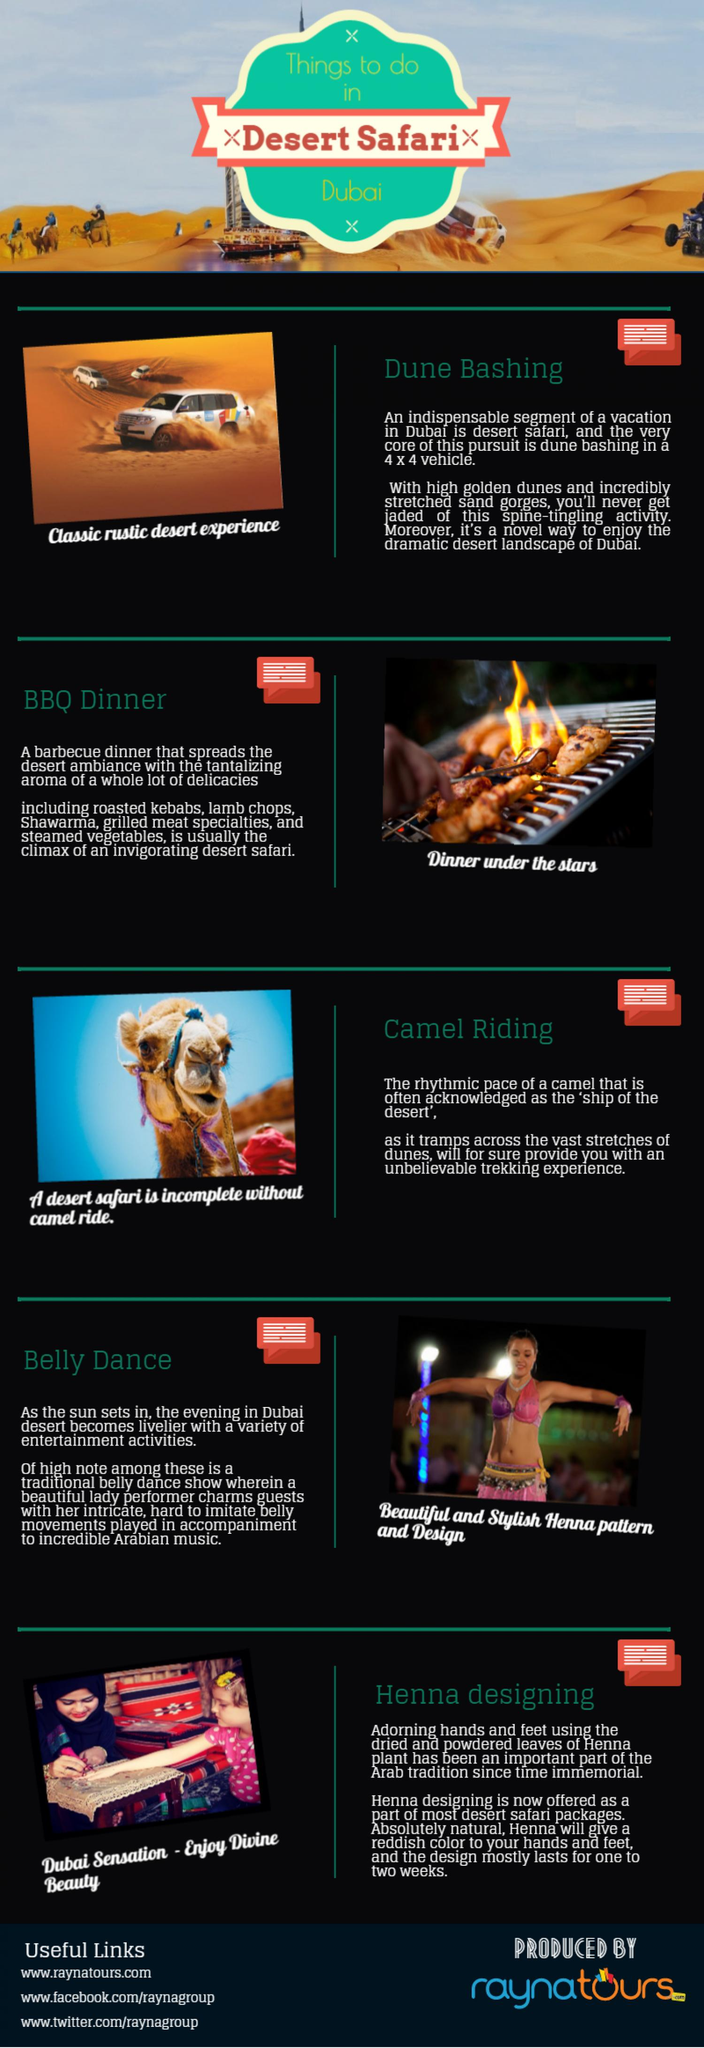Point out several critical features in this image. The third infographic visualizes camel riding. The fourth infographic visualizes Belly Dance. The segment of desert safari that is deemed to be of utmost importance is dune bashing. There are five activities to enjoy on a desert safari in Dubai. 